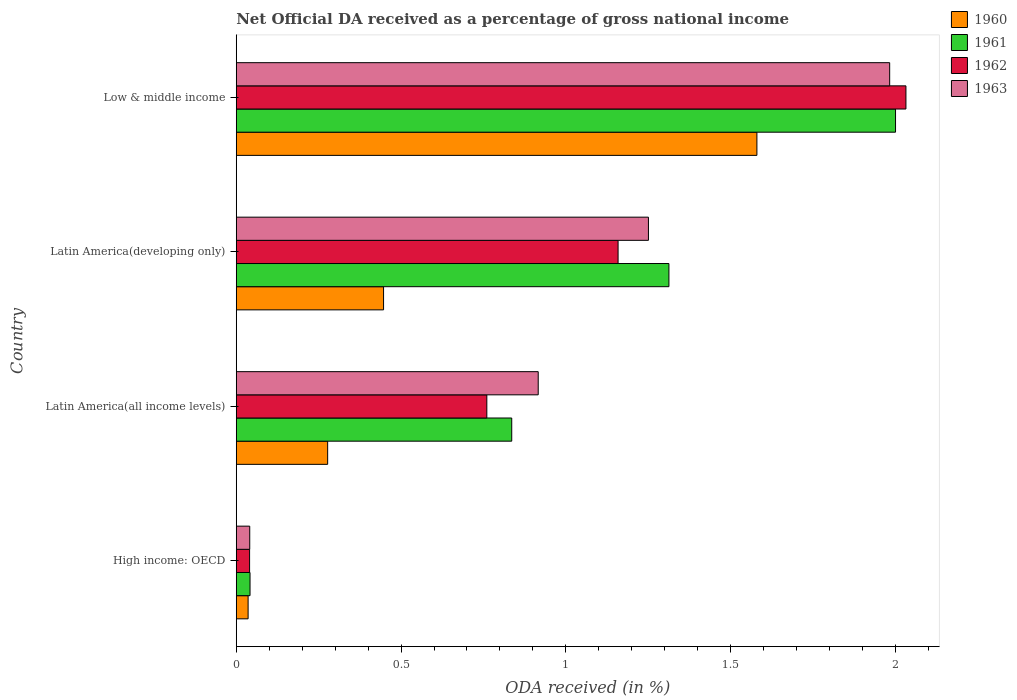How many different coloured bars are there?
Give a very brief answer. 4. Are the number of bars per tick equal to the number of legend labels?
Give a very brief answer. Yes. Are the number of bars on each tick of the Y-axis equal?
Provide a succinct answer. Yes. What is the label of the 2nd group of bars from the top?
Offer a terse response. Latin America(developing only). What is the net official DA received in 1961 in Latin America(developing only)?
Make the answer very short. 1.31. Across all countries, what is the maximum net official DA received in 1963?
Provide a short and direct response. 1.98. Across all countries, what is the minimum net official DA received in 1961?
Make the answer very short. 0.04. In which country was the net official DA received in 1960 minimum?
Your answer should be compact. High income: OECD. What is the total net official DA received in 1960 in the graph?
Your answer should be compact. 2.34. What is the difference between the net official DA received in 1961 in High income: OECD and that in Low & middle income?
Make the answer very short. -1.96. What is the difference between the net official DA received in 1963 in Latin America(all income levels) and the net official DA received in 1960 in Low & middle income?
Make the answer very short. -0.66. What is the average net official DA received in 1963 per country?
Give a very brief answer. 1.05. What is the difference between the net official DA received in 1960 and net official DA received in 1962 in Latin America(developing only)?
Give a very brief answer. -0.71. What is the ratio of the net official DA received in 1963 in Latin America(developing only) to that in Low & middle income?
Offer a terse response. 0.63. Is the net official DA received in 1960 in High income: OECD less than that in Latin America(developing only)?
Your response must be concise. Yes. Is the difference between the net official DA received in 1960 in High income: OECD and Latin America(all income levels) greater than the difference between the net official DA received in 1962 in High income: OECD and Latin America(all income levels)?
Provide a succinct answer. Yes. What is the difference between the highest and the second highest net official DA received in 1961?
Give a very brief answer. 0.69. What is the difference between the highest and the lowest net official DA received in 1962?
Ensure brevity in your answer.  1.99. Is the sum of the net official DA received in 1961 in Latin America(all income levels) and Low & middle income greater than the maximum net official DA received in 1962 across all countries?
Offer a terse response. Yes. What does the 1st bar from the top in Low & middle income represents?
Provide a short and direct response. 1963. Is it the case that in every country, the sum of the net official DA received in 1960 and net official DA received in 1963 is greater than the net official DA received in 1961?
Make the answer very short. Yes. How many bars are there?
Ensure brevity in your answer.  16. How many countries are there in the graph?
Give a very brief answer. 4. What is the difference between two consecutive major ticks on the X-axis?
Offer a terse response. 0.5. Does the graph contain any zero values?
Make the answer very short. No. Does the graph contain grids?
Your answer should be very brief. No. Where does the legend appear in the graph?
Ensure brevity in your answer.  Top right. How many legend labels are there?
Keep it short and to the point. 4. What is the title of the graph?
Offer a terse response. Net Official DA received as a percentage of gross national income. Does "2010" appear as one of the legend labels in the graph?
Your answer should be very brief. No. What is the label or title of the X-axis?
Your response must be concise. ODA received (in %). What is the ODA received (in %) in 1960 in High income: OECD?
Your answer should be very brief. 0.04. What is the ODA received (in %) of 1961 in High income: OECD?
Give a very brief answer. 0.04. What is the ODA received (in %) of 1962 in High income: OECD?
Give a very brief answer. 0.04. What is the ODA received (in %) of 1963 in High income: OECD?
Offer a very short reply. 0.04. What is the ODA received (in %) in 1960 in Latin America(all income levels)?
Provide a succinct answer. 0.28. What is the ODA received (in %) of 1961 in Latin America(all income levels)?
Your answer should be very brief. 0.84. What is the ODA received (in %) of 1962 in Latin America(all income levels)?
Your response must be concise. 0.76. What is the ODA received (in %) in 1963 in Latin America(all income levels)?
Offer a terse response. 0.92. What is the ODA received (in %) of 1960 in Latin America(developing only)?
Offer a terse response. 0.45. What is the ODA received (in %) of 1961 in Latin America(developing only)?
Offer a terse response. 1.31. What is the ODA received (in %) in 1962 in Latin America(developing only)?
Make the answer very short. 1.16. What is the ODA received (in %) in 1963 in Latin America(developing only)?
Offer a very short reply. 1.25. What is the ODA received (in %) in 1960 in Low & middle income?
Ensure brevity in your answer.  1.58. What is the ODA received (in %) in 1961 in Low & middle income?
Offer a terse response. 2. What is the ODA received (in %) in 1962 in Low & middle income?
Your answer should be very brief. 2.03. What is the ODA received (in %) in 1963 in Low & middle income?
Ensure brevity in your answer.  1.98. Across all countries, what is the maximum ODA received (in %) of 1960?
Ensure brevity in your answer.  1.58. Across all countries, what is the maximum ODA received (in %) of 1961?
Provide a short and direct response. 2. Across all countries, what is the maximum ODA received (in %) of 1962?
Offer a very short reply. 2.03. Across all countries, what is the maximum ODA received (in %) in 1963?
Your answer should be very brief. 1.98. Across all countries, what is the minimum ODA received (in %) of 1960?
Ensure brevity in your answer.  0.04. Across all countries, what is the minimum ODA received (in %) of 1961?
Ensure brevity in your answer.  0.04. Across all countries, what is the minimum ODA received (in %) in 1962?
Provide a succinct answer. 0.04. Across all countries, what is the minimum ODA received (in %) in 1963?
Ensure brevity in your answer.  0.04. What is the total ODA received (in %) of 1960 in the graph?
Your answer should be very brief. 2.34. What is the total ODA received (in %) in 1961 in the graph?
Make the answer very short. 4.19. What is the total ODA received (in %) of 1962 in the graph?
Provide a short and direct response. 3.99. What is the total ODA received (in %) of 1963 in the graph?
Ensure brevity in your answer.  4.19. What is the difference between the ODA received (in %) in 1960 in High income: OECD and that in Latin America(all income levels)?
Give a very brief answer. -0.24. What is the difference between the ODA received (in %) in 1961 in High income: OECD and that in Latin America(all income levels)?
Provide a succinct answer. -0.79. What is the difference between the ODA received (in %) of 1962 in High income: OECD and that in Latin America(all income levels)?
Offer a very short reply. -0.72. What is the difference between the ODA received (in %) of 1963 in High income: OECD and that in Latin America(all income levels)?
Offer a terse response. -0.88. What is the difference between the ODA received (in %) in 1960 in High income: OECD and that in Latin America(developing only)?
Provide a succinct answer. -0.41. What is the difference between the ODA received (in %) in 1961 in High income: OECD and that in Latin America(developing only)?
Your answer should be compact. -1.27. What is the difference between the ODA received (in %) of 1962 in High income: OECD and that in Latin America(developing only)?
Offer a terse response. -1.12. What is the difference between the ODA received (in %) in 1963 in High income: OECD and that in Latin America(developing only)?
Provide a short and direct response. -1.21. What is the difference between the ODA received (in %) of 1960 in High income: OECD and that in Low & middle income?
Provide a short and direct response. -1.54. What is the difference between the ODA received (in %) of 1961 in High income: OECD and that in Low & middle income?
Keep it short and to the point. -1.96. What is the difference between the ODA received (in %) in 1962 in High income: OECD and that in Low & middle income?
Your answer should be compact. -1.99. What is the difference between the ODA received (in %) in 1963 in High income: OECD and that in Low & middle income?
Your response must be concise. -1.94. What is the difference between the ODA received (in %) of 1960 in Latin America(all income levels) and that in Latin America(developing only)?
Your answer should be very brief. -0.17. What is the difference between the ODA received (in %) in 1961 in Latin America(all income levels) and that in Latin America(developing only)?
Make the answer very short. -0.48. What is the difference between the ODA received (in %) of 1962 in Latin America(all income levels) and that in Latin America(developing only)?
Provide a short and direct response. -0.4. What is the difference between the ODA received (in %) in 1963 in Latin America(all income levels) and that in Latin America(developing only)?
Make the answer very short. -0.33. What is the difference between the ODA received (in %) in 1960 in Latin America(all income levels) and that in Low & middle income?
Your response must be concise. -1.3. What is the difference between the ODA received (in %) of 1961 in Latin America(all income levels) and that in Low & middle income?
Your answer should be compact. -1.16. What is the difference between the ODA received (in %) in 1962 in Latin America(all income levels) and that in Low & middle income?
Keep it short and to the point. -1.27. What is the difference between the ODA received (in %) of 1963 in Latin America(all income levels) and that in Low & middle income?
Your answer should be compact. -1.07. What is the difference between the ODA received (in %) of 1960 in Latin America(developing only) and that in Low & middle income?
Provide a short and direct response. -1.13. What is the difference between the ODA received (in %) of 1961 in Latin America(developing only) and that in Low & middle income?
Provide a succinct answer. -0.69. What is the difference between the ODA received (in %) in 1962 in Latin America(developing only) and that in Low & middle income?
Make the answer very short. -0.87. What is the difference between the ODA received (in %) in 1963 in Latin America(developing only) and that in Low & middle income?
Your answer should be compact. -0.73. What is the difference between the ODA received (in %) in 1960 in High income: OECD and the ODA received (in %) in 1961 in Latin America(all income levels)?
Ensure brevity in your answer.  -0.8. What is the difference between the ODA received (in %) in 1960 in High income: OECD and the ODA received (in %) in 1962 in Latin America(all income levels)?
Offer a very short reply. -0.72. What is the difference between the ODA received (in %) in 1960 in High income: OECD and the ODA received (in %) in 1963 in Latin America(all income levels)?
Provide a succinct answer. -0.88. What is the difference between the ODA received (in %) of 1961 in High income: OECD and the ODA received (in %) of 1962 in Latin America(all income levels)?
Give a very brief answer. -0.72. What is the difference between the ODA received (in %) of 1961 in High income: OECD and the ODA received (in %) of 1963 in Latin America(all income levels)?
Provide a short and direct response. -0.87. What is the difference between the ODA received (in %) of 1962 in High income: OECD and the ODA received (in %) of 1963 in Latin America(all income levels)?
Provide a short and direct response. -0.88. What is the difference between the ODA received (in %) in 1960 in High income: OECD and the ODA received (in %) in 1961 in Latin America(developing only)?
Offer a terse response. -1.28. What is the difference between the ODA received (in %) of 1960 in High income: OECD and the ODA received (in %) of 1962 in Latin America(developing only)?
Your response must be concise. -1.12. What is the difference between the ODA received (in %) of 1960 in High income: OECD and the ODA received (in %) of 1963 in Latin America(developing only)?
Provide a succinct answer. -1.21. What is the difference between the ODA received (in %) of 1961 in High income: OECD and the ODA received (in %) of 1962 in Latin America(developing only)?
Provide a succinct answer. -1.12. What is the difference between the ODA received (in %) in 1961 in High income: OECD and the ODA received (in %) in 1963 in Latin America(developing only)?
Provide a short and direct response. -1.21. What is the difference between the ODA received (in %) in 1962 in High income: OECD and the ODA received (in %) in 1963 in Latin America(developing only)?
Provide a succinct answer. -1.21. What is the difference between the ODA received (in %) in 1960 in High income: OECD and the ODA received (in %) in 1961 in Low & middle income?
Offer a terse response. -1.96. What is the difference between the ODA received (in %) in 1960 in High income: OECD and the ODA received (in %) in 1962 in Low & middle income?
Your answer should be very brief. -2. What is the difference between the ODA received (in %) of 1960 in High income: OECD and the ODA received (in %) of 1963 in Low & middle income?
Provide a short and direct response. -1.95. What is the difference between the ODA received (in %) in 1961 in High income: OECD and the ODA received (in %) in 1962 in Low & middle income?
Keep it short and to the point. -1.99. What is the difference between the ODA received (in %) of 1961 in High income: OECD and the ODA received (in %) of 1963 in Low & middle income?
Give a very brief answer. -1.94. What is the difference between the ODA received (in %) in 1962 in High income: OECD and the ODA received (in %) in 1963 in Low & middle income?
Offer a very short reply. -1.94. What is the difference between the ODA received (in %) in 1960 in Latin America(all income levels) and the ODA received (in %) in 1961 in Latin America(developing only)?
Give a very brief answer. -1.04. What is the difference between the ODA received (in %) of 1960 in Latin America(all income levels) and the ODA received (in %) of 1962 in Latin America(developing only)?
Your response must be concise. -0.88. What is the difference between the ODA received (in %) in 1960 in Latin America(all income levels) and the ODA received (in %) in 1963 in Latin America(developing only)?
Your answer should be very brief. -0.97. What is the difference between the ODA received (in %) of 1961 in Latin America(all income levels) and the ODA received (in %) of 1962 in Latin America(developing only)?
Ensure brevity in your answer.  -0.32. What is the difference between the ODA received (in %) of 1961 in Latin America(all income levels) and the ODA received (in %) of 1963 in Latin America(developing only)?
Ensure brevity in your answer.  -0.41. What is the difference between the ODA received (in %) of 1962 in Latin America(all income levels) and the ODA received (in %) of 1963 in Latin America(developing only)?
Offer a very short reply. -0.49. What is the difference between the ODA received (in %) of 1960 in Latin America(all income levels) and the ODA received (in %) of 1961 in Low & middle income?
Your answer should be very brief. -1.72. What is the difference between the ODA received (in %) in 1960 in Latin America(all income levels) and the ODA received (in %) in 1962 in Low & middle income?
Your answer should be very brief. -1.75. What is the difference between the ODA received (in %) of 1960 in Latin America(all income levels) and the ODA received (in %) of 1963 in Low & middle income?
Provide a succinct answer. -1.71. What is the difference between the ODA received (in %) of 1961 in Latin America(all income levels) and the ODA received (in %) of 1962 in Low & middle income?
Your answer should be compact. -1.2. What is the difference between the ODA received (in %) in 1961 in Latin America(all income levels) and the ODA received (in %) in 1963 in Low & middle income?
Offer a very short reply. -1.15. What is the difference between the ODA received (in %) of 1962 in Latin America(all income levels) and the ODA received (in %) of 1963 in Low & middle income?
Offer a very short reply. -1.22. What is the difference between the ODA received (in %) of 1960 in Latin America(developing only) and the ODA received (in %) of 1961 in Low & middle income?
Offer a terse response. -1.55. What is the difference between the ODA received (in %) in 1960 in Latin America(developing only) and the ODA received (in %) in 1962 in Low & middle income?
Provide a succinct answer. -1.58. What is the difference between the ODA received (in %) in 1960 in Latin America(developing only) and the ODA received (in %) in 1963 in Low & middle income?
Provide a succinct answer. -1.54. What is the difference between the ODA received (in %) of 1961 in Latin America(developing only) and the ODA received (in %) of 1962 in Low & middle income?
Keep it short and to the point. -0.72. What is the difference between the ODA received (in %) of 1961 in Latin America(developing only) and the ODA received (in %) of 1963 in Low & middle income?
Keep it short and to the point. -0.67. What is the difference between the ODA received (in %) of 1962 in Latin America(developing only) and the ODA received (in %) of 1963 in Low & middle income?
Your response must be concise. -0.82. What is the average ODA received (in %) of 1960 per country?
Your answer should be very brief. 0.58. What is the average ODA received (in %) of 1961 per country?
Give a very brief answer. 1.05. What is the average ODA received (in %) of 1963 per country?
Ensure brevity in your answer.  1.05. What is the difference between the ODA received (in %) of 1960 and ODA received (in %) of 1961 in High income: OECD?
Provide a short and direct response. -0.01. What is the difference between the ODA received (in %) in 1960 and ODA received (in %) in 1962 in High income: OECD?
Your answer should be compact. -0. What is the difference between the ODA received (in %) of 1960 and ODA received (in %) of 1963 in High income: OECD?
Ensure brevity in your answer.  -0.01. What is the difference between the ODA received (in %) of 1961 and ODA received (in %) of 1962 in High income: OECD?
Make the answer very short. 0. What is the difference between the ODA received (in %) in 1961 and ODA received (in %) in 1963 in High income: OECD?
Offer a very short reply. 0. What is the difference between the ODA received (in %) in 1962 and ODA received (in %) in 1963 in High income: OECD?
Keep it short and to the point. -0. What is the difference between the ODA received (in %) in 1960 and ODA received (in %) in 1961 in Latin America(all income levels)?
Give a very brief answer. -0.56. What is the difference between the ODA received (in %) in 1960 and ODA received (in %) in 1962 in Latin America(all income levels)?
Provide a short and direct response. -0.48. What is the difference between the ODA received (in %) of 1960 and ODA received (in %) of 1963 in Latin America(all income levels)?
Your answer should be compact. -0.64. What is the difference between the ODA received (in %) in 1961 and ODA received (in %) in 1962 in Latin America(all income levels)?
Offer a terse response. 0.08. What is the difference between the ODA received (in %) in 1961 and ODA received (in %) in 1963 in Latin America(all income levels)?
Make the answer very short. -0.08. What is the difference between the ODA received (in %) in 1962 and ODA received (in %) in 1963 in Latin America(all income levels)?
Your answer should be very brief. -0.16. What is the difference between the ODA received (in %) of 1960 and ODA received (in %) of 1961 in Latin America(developing only)?
Make the answer very short. -0.87. What is the difference between the ODA received (in %) of 1960 and ODA received (in %) of 1962 in Latin America(developing only)?
Ensure brevity in your answer.  -0.71. What is the difference between the ODA received (in %) of 1960 and ODA received (in %) of 1963 in Latin America(developing only)?
Ensure brevity in your answer.  -0.8. What is the difference between the ODA received (in %) in 1961 and ODA received (in %) in 1962 in Latin America(developing only)?
Make the answer very short. 0.15. What is the difference between the ODA received (in %) in 1961 and ODA received (in %) in 1963 in Latin America(developing only)?
Offer a terse response. 0.06. What is the difference between the ODA received (in %) in 1962 and ODA received (in %) in 1963 in Latin America(developing only)?
Your answer should be very brief. -0.09. What is the difference between the ODA received (in %) in 1960 and ODA received (in %) in 1961 in Low & middle income?
Ensure brevity in your answer.  -0.42. What is the difference between the ODA received (in %) of 1960 and ODA received (in %) of 1962 in Low & middle income?
Offer a terse response. -0.45. What is the difference between the ODA received (in %) of 1960 and ODA received (in %) of 1963 in Low & middle income?
Provide a short and direct response. -0.4. What is the difference between the ODA received (in %) in 1961 and ODA received (in %) in 1962 in Low & middle income?
Your answer should be very brief. -0.03. What is the difference between the ODA received (in %) in 1961 and ODA received (in %) in 1963 in Low & middle income?
Your answer should be very brief. 0.02. What is the difference between the ODA received (in %) in 1962 and ODA received (in %) in 1963 in Low & middle income?
Make the answer very short. 0.05. What is the ratio of the ODA received (in %) of 1960 in High income: OECD to that in Latin America(all income levels)?
Offer a very short reply. 0.13. What is the ratio of the ODA received (in %) of 1962 in High income: OECD to that in Latin America(all income levels)?
Offer a very short reply. 0.05. What is the ratio of the ODA received (in %) in 1963 in High income: OECD to that in Latin America(all income levels)?
Give a very brief answer. 0.04. What is the ratio of the ODA received (in %) of 1960 in High income: OECD to that in Latin America(developing only)?
Offer a very short reply. 0.08. What is the ratio of the ODA received (in %) of 1961 in High income: OECD to that in Latin America(developing only)?
Make the answer very short. 0.03. What is the ratio of the ODA received (in %) in 1962 in High income: OECD to that in Latin America(developing only)?
Your response must be concise. 0.04. What is the ratio of the ODA received (in %) of 1963 in High income: OECD to that in Latin America(developing only)?
Offer a very short reply. 0.03. What is the ratio of the ODA received (in %) in 1960 in High income: OECD to that in Low & middle income?
Provide a succinct answer. 0.02. What is the ratio of the ODA received (in %) of 1961 in High income: OECD to that in Low & middle income?
Your answer should be very brief. 0.02. What is the ratio of the ODA received (in %) in 1962 in High income: OECD to that in Low & middle income?
Make the answer very short. 0.02. What is the ratio of the ODA received (in %) of 1963 in High income: OECD to that in Low & middle income?
Provide a succinct answer. 0.02. What is the ratio of the ODA received (in %) of 1960 in Latin America(all income levels) to that in Latin America(developing only)?
Provide a short and direct response. 0.62. What is the ratio of the ODA received (in %) of 1961 in Latin America(all income levels) to that in Latin America(developing only)?
Offer a very short reply. 0.64. What is the ratio of the ODA received (in %) of 1962 in Latin America(all income levels) to that in Latin America(developing only)?
Ensure brevity in your answer.  0.66. What is the ratio of the ODA received (in %) of 1963 in Latin America(all income levels) to that in Latin America(developing only)?
Provide a short and direct response. 0.73. What is the ratio of the ODA received (in %) of 1960 in Latin America(all income levels) to that in Low & middle income?
Your answer should be compact. 0.18. What is the ratio of the ODA received (in %) in 1961 in Latin America(all income levels) to that in Low & middle income?
Provide a short and direct response. 0.42. What is the ratio of the ODA received (in %) in 1962 in Latin America(all income levels) to that in Low & middle income?
Offer a terse response. 0.37. What is the ratio of the ODA received (in %) of 1963 in Latin America(all income levels) to that in Low & middle income?
Your answer should be very brief. 0.46. What is the ratio of the ODA received (in %) in 1960 in Latin America(developing only) to that in Low & middle income?
Make the answer very short. 0.28. What is the ratio of the ODA received (in %) of 1961 in Latin America(developing only) to that in Low & middle income?
Your response must be concise. 0.66. What is the ratio of the ODA received (in %) of 1962 in Latin America(developing only) to that in Low & middle income?
Your answer should be very brief. 0.57. What is the ratio of the ODA received (in %) of 1963 in Latin America(developing only) to that in Low & middle income?
Your answer should be very brief. 0.63. What is the difference between the highest and the second highest ODA received (in %) of 1960?
Your answer should be very brief. 1.13. What is the difference between the highest and the second highest ODA received (in %) of 1961?
Offer a very short reply. 0.69. What is the difference between the highest and the second highest ODA received (in %) of 1962?
Make the answer very short. 0.87. What is the difference between the highest and the second highest ODA received (in %) of 1963?
Your response must be concise. 0.73. What is the difference between the highest and the lowest ODA received (in %) in 1960?
Keep it short and to the point. 1.54. What is the difference between the highest and the lowest ODA received (in %) in 1961?
Your response must be concise. 1.96. What is the difference between the highest and the lowest ODA received (in %) in 1962?
Your answer should be compact. 1.99. What is the difference between the highest and the lowest ODA received (in %) in 1963?
Offer a very short reply. 1.94. 